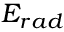<formula> <loc_0><loc_0><loc_500><loc_500>E _ { r a d }</formula> 